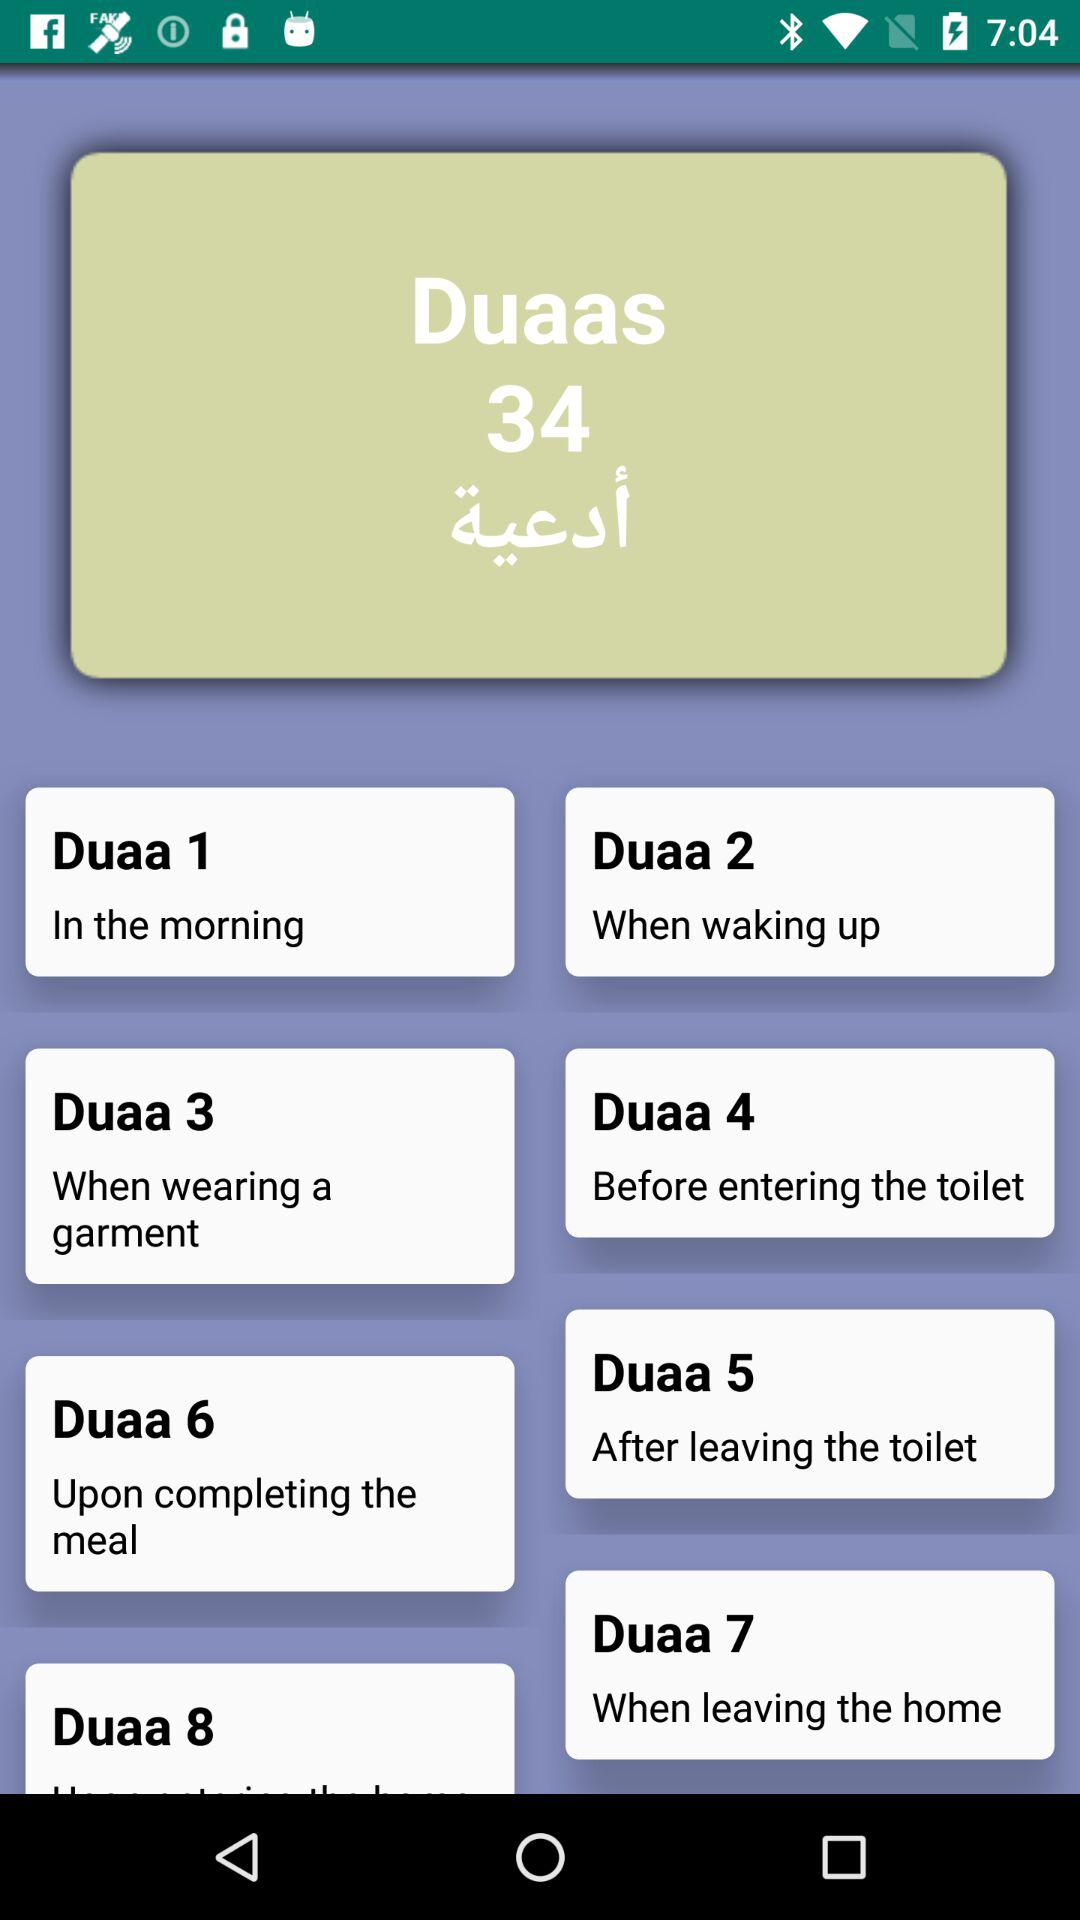When is "Duaa 1" recited? "Duaa 1" is recited in the morning. 